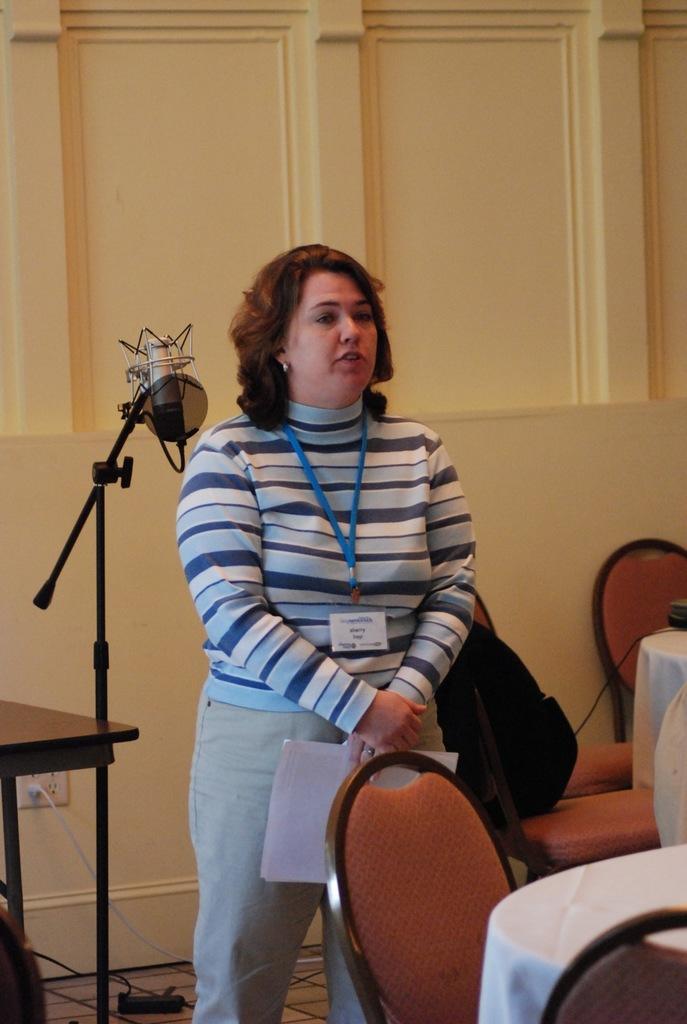Describe this image in one or two sentences. Here we can see a woman is standing on the floor, and wearing an id card, and holding papers in the hand, and here is the chair, and in front here is the table. 